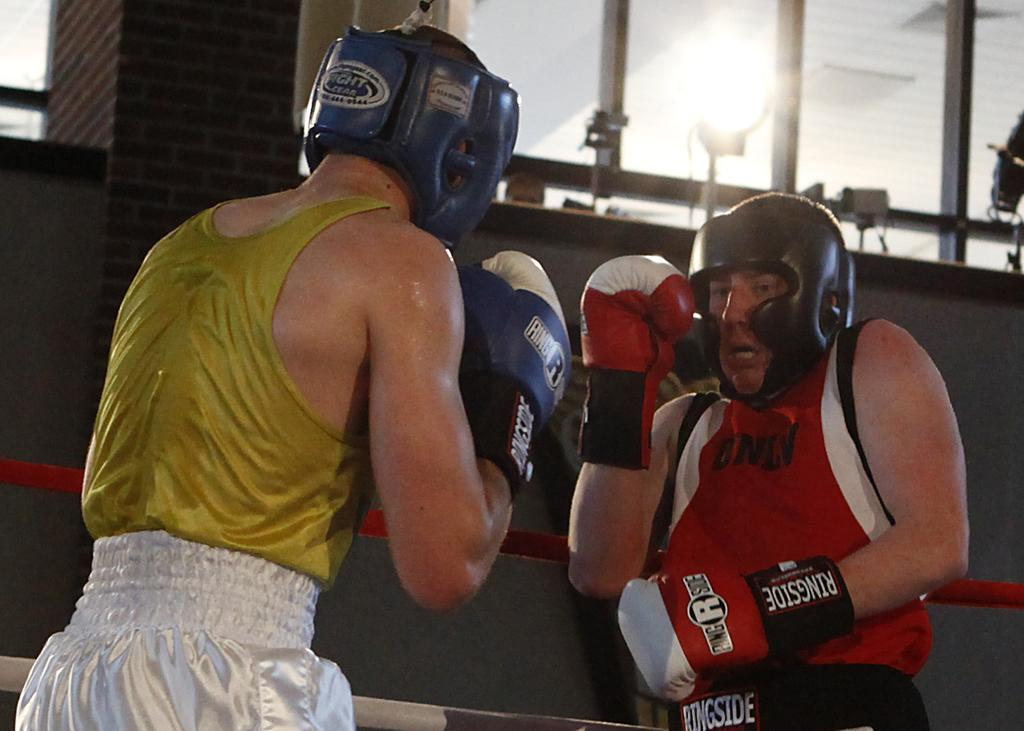Provide a one-sentence caption for the provided image. Two boxers wearing ringside brand kit fight in a boxing ring. 